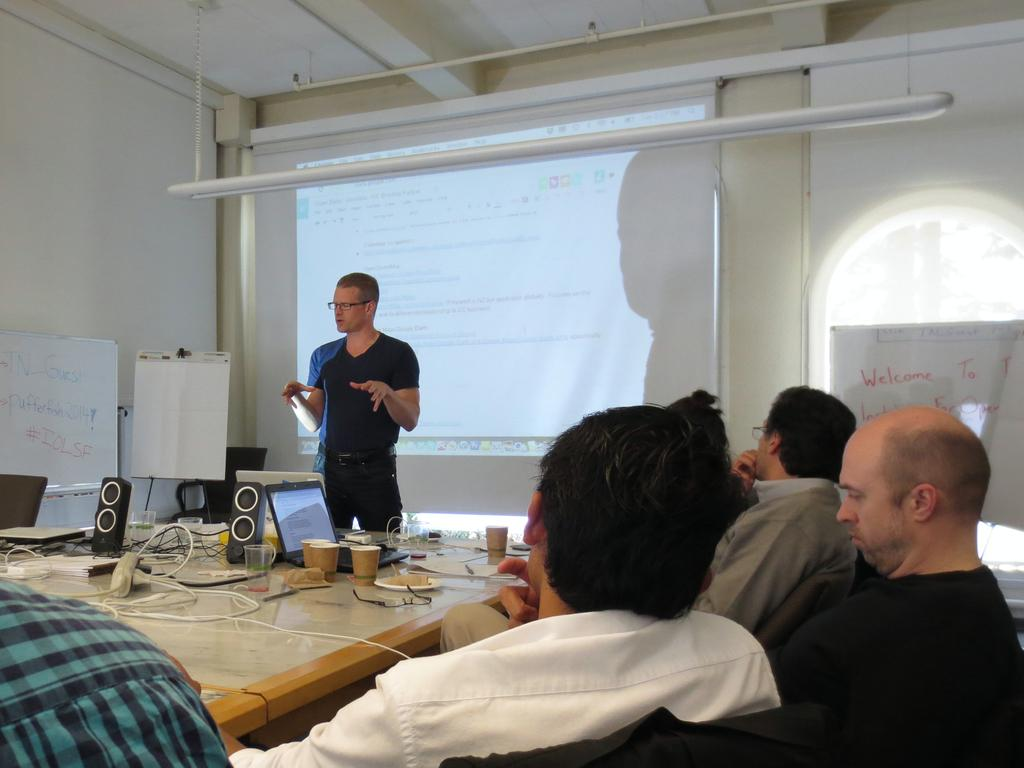What type of room is depicted in the image? The image shows an inner view of a meeting room. What equipment is present in the room? There is a projector in the room. How are the people in the room arranged? People are seated in chairs in the room. What items can be seen on the table in the room? There are glasses on a table in the room. What device might be used for presentations in the room? A laptop is present in the room. What type of stick can be seen holding the attention of the people in the image? There is no stick present in the image, and the people's attention is not being held by any object. What type of jar is visible on the table in the image? There is no jar present on the table in the image. 